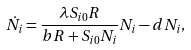<formula> <loc_0><loc_0><loc_500><loc_500>\dot { N } _ { i } = \frac { \lambda S _ { i 0 } R } { b R + S _ { i 0 } N _ { i } } N _ { i } - d N _ { i } ,</formula> 